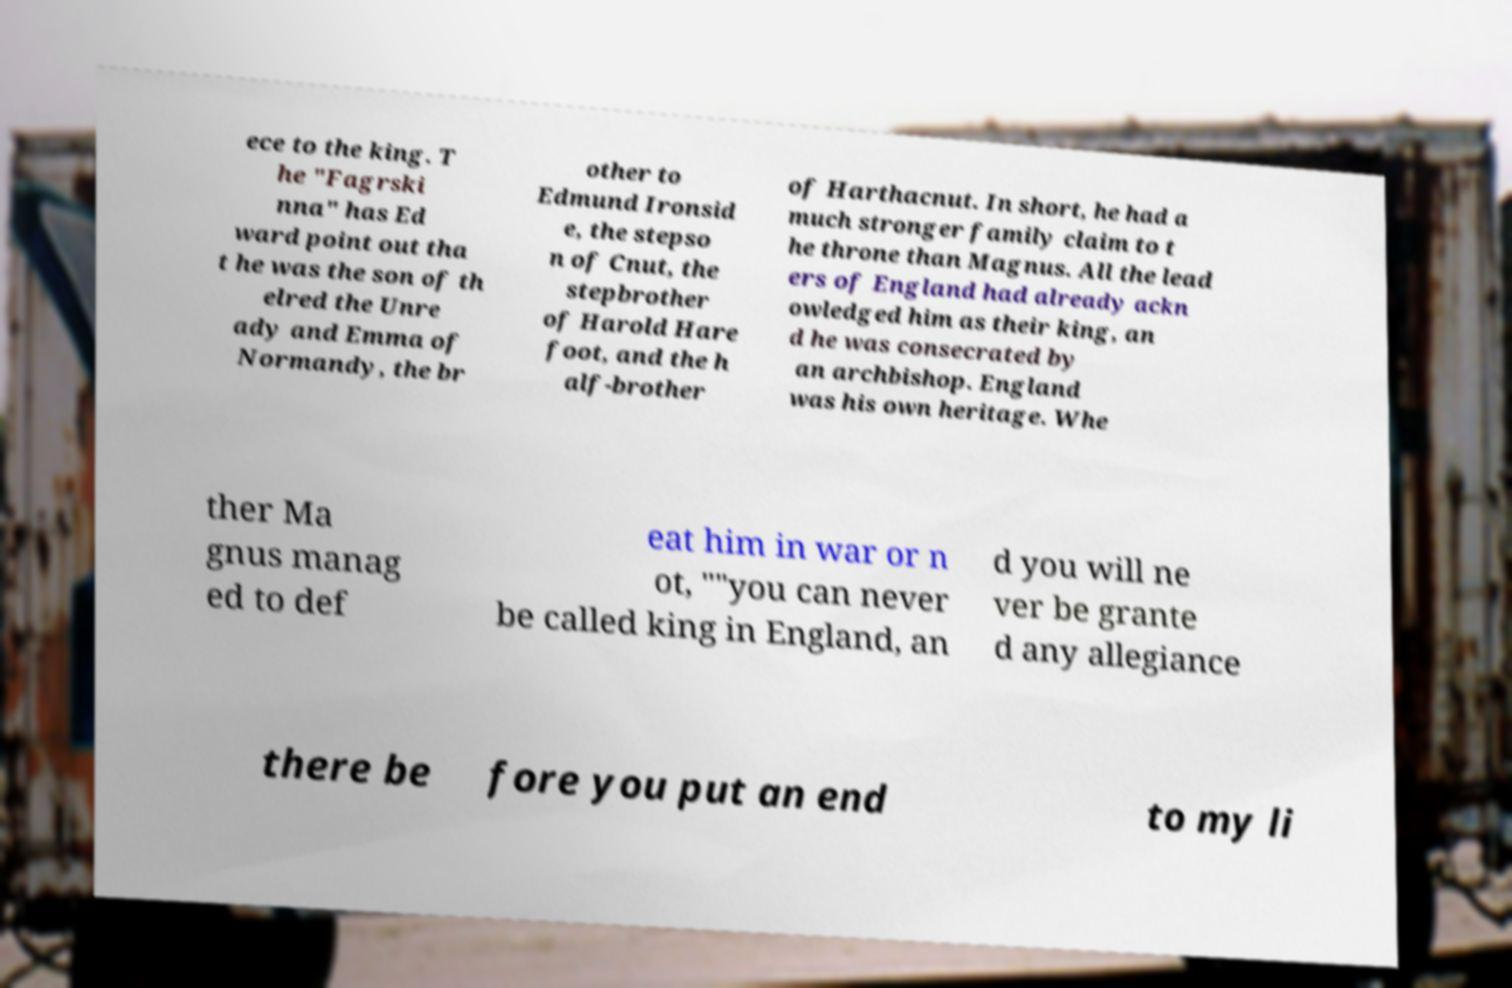Could you extract and type out the text from this image? ece to the king. T he "Fagrski nna" has Ed ward point out tha t he was the son of th elred the Unre ady and Emma of Normandy, the br other to Edmund Ironsid e, the stepso n of Cnut, the stepbrother of Harold Hare foot, and the h alf-brother of Harthacnut. In short, he had a much stronger family claim to t he throne than Magnus. All the lead ers of England had already ackn owledged him as their king, an d he was consecrated by an archbishop. England was his own heritage. Whe ther Ma gnus manag ed to def eat him in war or n ot, ""you can never be called king in England, an d you will ne ver be grante d any allegiance there be fore you put an end to my li 